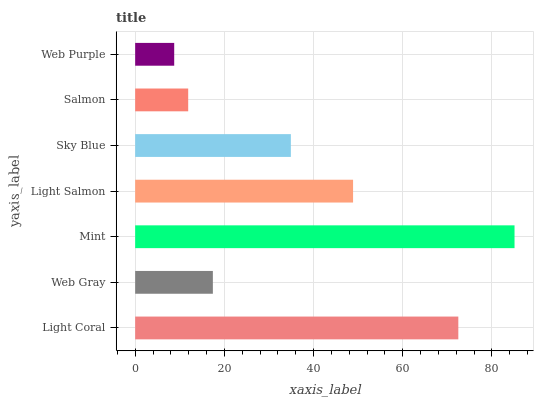Is Web Purple the minimum?
Answer yes or no. Yes. Is Mint the maximum?
Answer yes or no. Yes. Is Web Gray the minimum?
Answer yes or no. No. Is Web Gray the maximum?
Answer yes or no. No. Is Light Coral greater than Web Gray?
Answer yes or no. Yes. Is Web Gray less than Light Coral?
Answer yes or no. Yes. Is Web Gray greater than Light Coral?
Answer yes or no. No. Is Light Coral less than Web Gray?
Answer yes or no. No. Is Sky Blue the high median?
Answer yes or no. Yes. Is Sky Blue the low median?
Answer yes or no. Yes. Is Mint the high median?
Answer yes or no. No. Is Mint the low median?
Answer yes or no. No. 